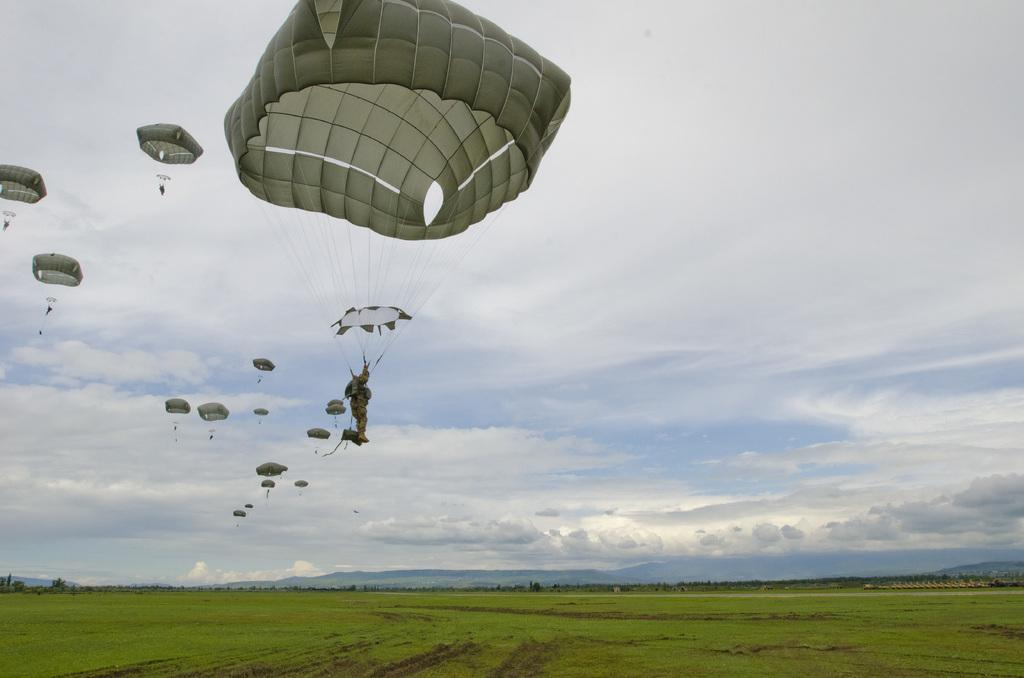What is visible in the sky in the image? There are parachutes in the sky. What type of surface can be seen at the bottom of the image? There is grass visible at the bottom of the image. What type of salt is being used to pickle the parachutes in the image? There is no salt or pickling process depicted in the image; it simply shows parachutes in the sky and grass at the bottom. 